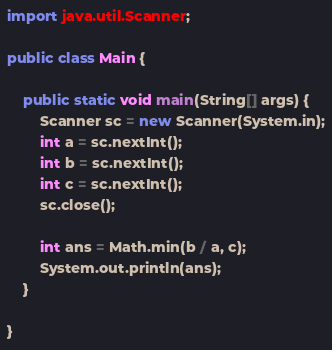<code> <loc_0><loc_0><loc_500><loc_500><_Java_>import java.util.Scanner;

public class Main {

    public static void main(String[] args) {
        Scanner sc = new Scanner(System.in);
        int a = sc.nextInt();
        int b = sc.nextInt();
        int c = sc.nextInt();
        sc.close();

        int ans = Math.min(b / a, c);
        System.out.println(ans);
    }

}
</code> 